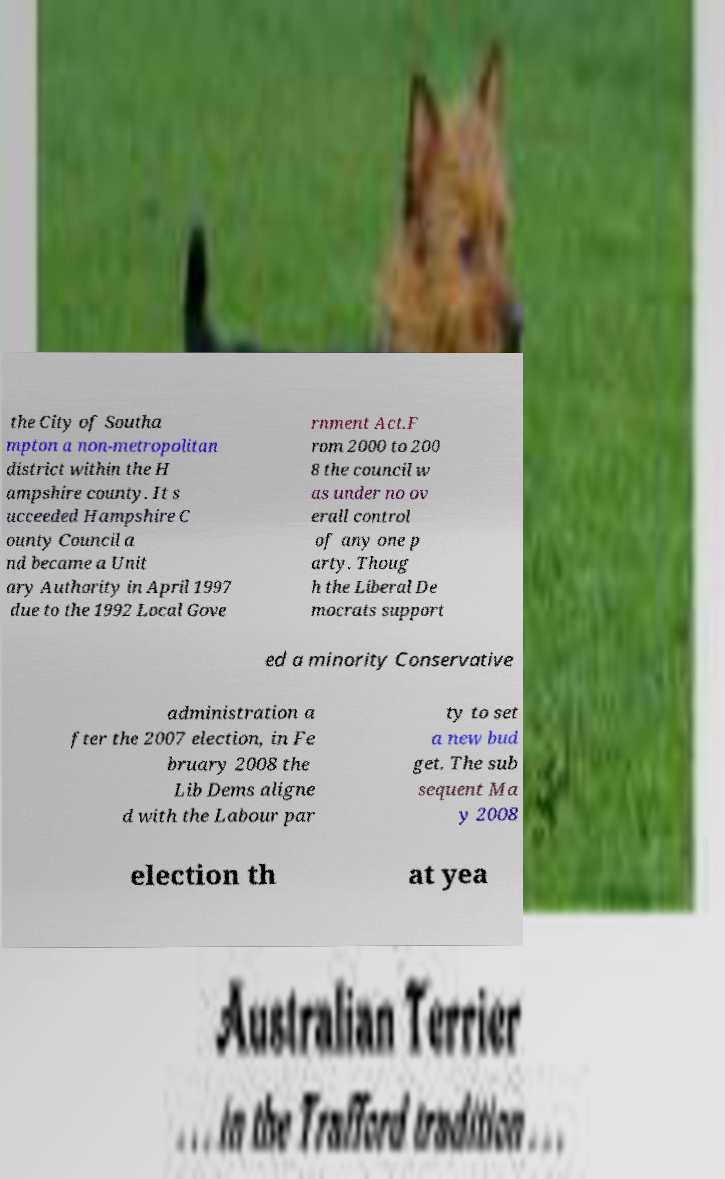For documentation purposes, I need the text within this image transcribed. Could you provide that? the City of Southa mpton a non-metropolitan district within the H ampshire county. It s ucceeded Hampshire C ounty Council a nd became a Unit ary Authority in April 1997 due to the 1992 Local Gove rnment Act.F rom 2000 to 200 8 the council w as under no ov erall control of any one p arty. Thoug h the Liberal De mocrats support ed a minority Conservative administration a fter the 2007 election, in Fe bruary 2008 the Lib Dems aligne d with the Labour par ty to set a new bud get. The sub sequent Ma y 2008 election th at yea 